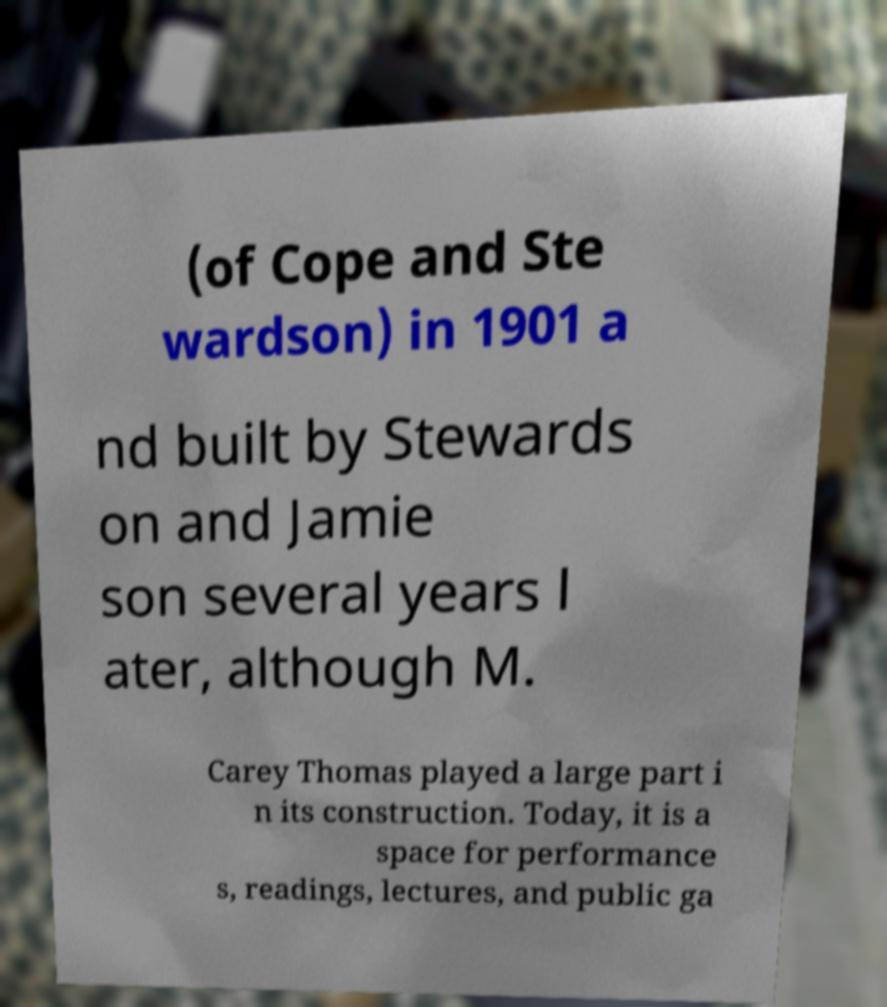I need the written content from this picture converted into text. Can you do that? (of Cope and Ste wardson) in 1901 a nd built by Stewards on and Jamie son several years l ater, although M. Carey Thomas played a large part i n its construction. Today, it is a space for performance s, readings, lectures, and public ga 